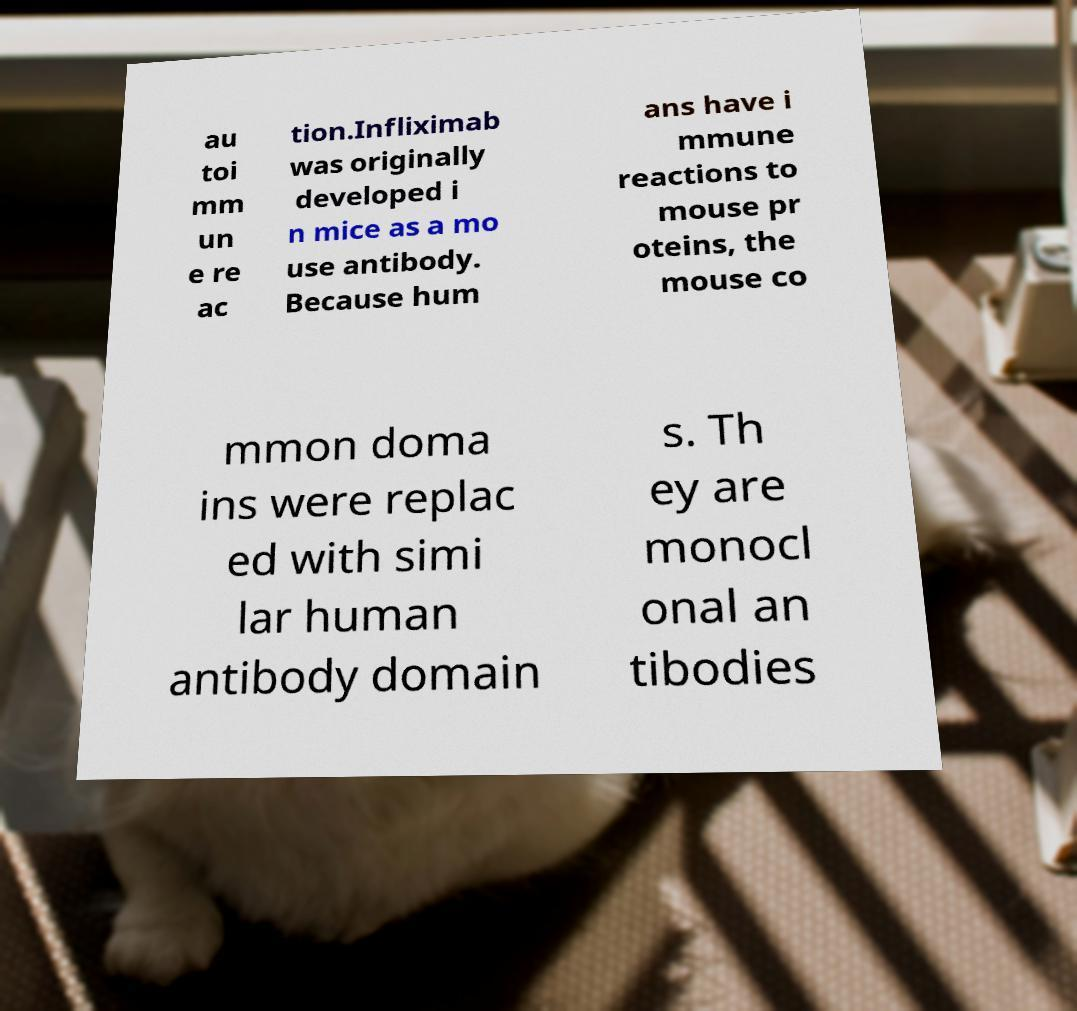Please read and relay the text visible in this image. What does it say? au toi mm un e re ac tion.Infliximab was originally developed i n mice as a mo use antibody. Because hum ans have i mmune reactions to mouse pr oteins, the mouse co mmon doma ins were replac ed with simi lar human antibody domain s. Th ey are monocl onal an tibodies 